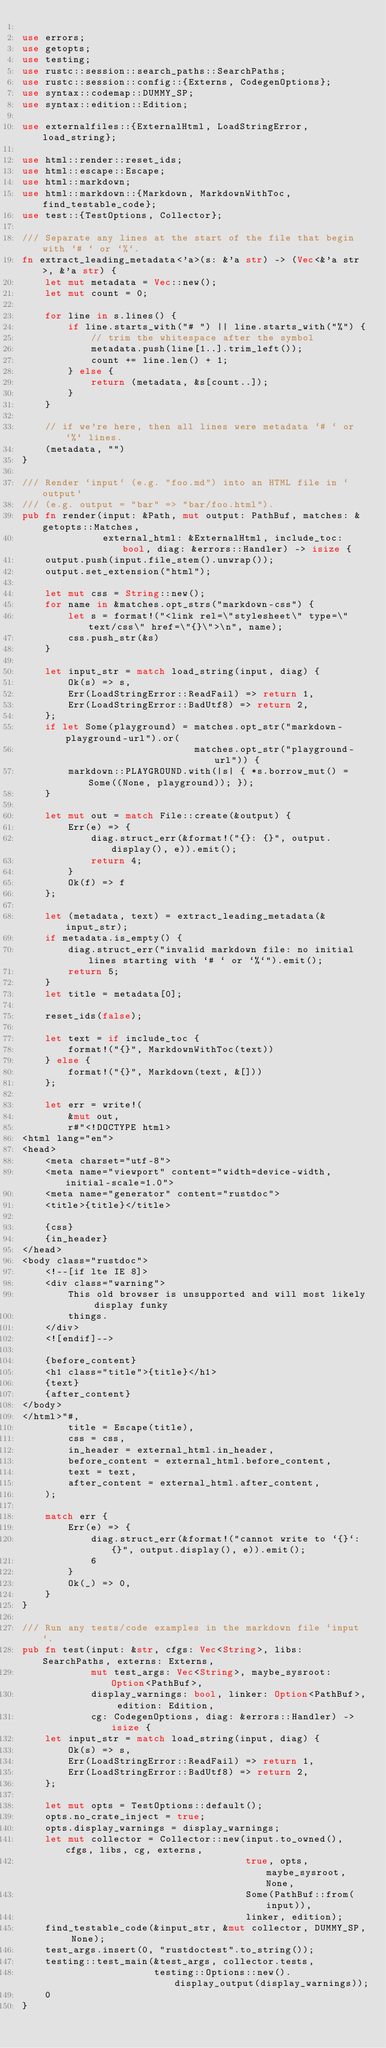Convert code to text. <code><loc_0><loc_0><loc_500><loc_500><_Rust_>
use errors;
use getopts;
use testing;
use rustc::session::search_paths::SearchPaths;
use rustc::session::config::{Externs, CodegenOptions};
use syntax::codemap::DUMMY_SP;
use syntax::edition::Edition;

use externalfiles::{ExternalHtml, LoadStringError, load_string};

use html::render::reset_ids;
use html::escape::Escape;
use html::markdown;
use html::markdown::{Markdown, MarkdownWithToc, find_testable_code};
use test::{TestOptions, Collector};

/// Separate any lines at the start of the file that begin with `# ` or `%`.
fn extract_leading_metadata<'a>(s: &'a str) -> (Vec<&'a str>, &'a str) {
    let mut metadata = Vec::new();
    let mut count = 0;

    for line in s.lines() {
        if line.starts_with("# ") || line.starts_with("%") {
            // trim the whitespace after the symbol
            metadata.push(line[1..].trim_left());
            count += line.len() + 1;
        } else {
            return (metadata, &s[count..]);
        }
    }

    // if we're here, then all lines were metadata `# ` or `%` lines.
    (metadata, "")
}

/// Render `input` (e.g. "foo.md") into an HTML file in `output`
/// (e.g. output = "bar" => "bar/foo.html").
pub fn render(input: &Path, mut output: PathBuf, matches: &getopts::Matches,
              external_html: &ExternalHtml, include_toc: bool, diag: &errors::Handler) -> isize {
    output.push(input.file_stem().unwrap());
    output.set_extension("html");

    let mut css = String::new();
    for name in &matches.opt_strs("markdown-css") {
        let s = format!("<link rel=\"stylesheet\" type=\"text/css\" href=\"{}\">\n", name);
        css.push_str(&s)
    }

    let input_str = match load_string(input, diag) {
        Ok(s) => s,
        Err(LoadStringError::ReadFail) => return 1,
        Err(LoadStringError::BadUtf8) => return 2,
    };
    if let Some(playground) = matches.opt_str("markdown-playground-url").or(
                              matches.opt_str("playground-url")) {
        markdown::PLAYGROUND.with(|s| { *s.borrow_mut() = Some((None, playground)); });
    }

    let mut out = match File::create(&output) {
        Err(e) => {
            diag.struct_err(&format!("{}: {}", output.display(), e)).emit();
            return 4;
        }
        Ok(f) => f
    };

    let (metadata, text) = extract_leading_metadata(&input_str);
    if metadata.is_empty() {
        diag.struct_err("invalid markdown file: no initial lines starting with `# ` or `%`").emit();
        return 5;
    }
    let title = metadata[0];

    reset_ids(false);

    let text = if include_toc {
        format!("{}", MarkdownWithToc(text))
    } else {
        format!("{}", Markdown(text, &[]))
    };

    let err = write!(
        &mut out,
        r#"<!DOCTYPE html>
<html lang="en">
<head>
    <meta charset="utf-8">
    <meta name="viewport" content="width=device-width, initial-scale=1.0">
    <meta name="generator" content="rustdoc">
    <title>{title}</title>

    {css}
    {in_header}
</head>
<body class="rustdoc">
    <!--[if lte IE 8]>
    <div class="warning">
        This old browser is unsupported and will most likely display funky
        things.
    </div>
    <![endif]-->

    {before_content}
    <h1 class="title">{title}</h1>
    {text}
    {after_content}
</body>
</html>"#,
        title = Escape(title),
        css = css,
        in_header = external_html.in_header,
        before_content = external_html.before_content,
        text = text,
        after_content = external_html.after_content,
    );

    match err {
        Err(e) => {
            diag.struct_err(&format!("cannot write to `{}`: {}", output.display(), e)).emit();
            6
        }
        Ok(_) => 0,
    }
}

/// Run any tests/code examples in the markdown file `input`.
pub fn test(input: &str, cfgs: Vec<String>, libs: SearchPaths, externs: Externs,
            mut test_args: Vec<String>, maybe_sysroot: Option<PathBuf>,
            display_warnings: bool, linker: Option<PathBuf>, edition: Edition,
            cg: CodegenOptions, diag: &errors::Handler) -> isize {
    let input_str = match load_string(input, diag) {
        Ok(s) => s,
        Err(LoadStringError::ReadFail) => return 1,
        Err(LoadStringError::BadUtf8) => return 2,
    };

    let mut opts = TestOptions::default();
    opts.no_crate_inject = true;
    opts.display_warnings = display_warnings;
    let mut collector = Collector::new(input.to_owned(), cfgs, libs, cg, externs,
                                       true, opts, maybe_sysroot, None,
                                       Some(PathBuf::from(input)),
                                       linker, edition);
    find_testable_code(&input_str, &mut collector, DUMMY_SP, None);
    test_args.insert(0, "rustdoctest".to_string());
    testing::test_main(&test_args, collector.tests,
                       testing::Options::new().display_output(display_warnings));
    0
}
</code> 